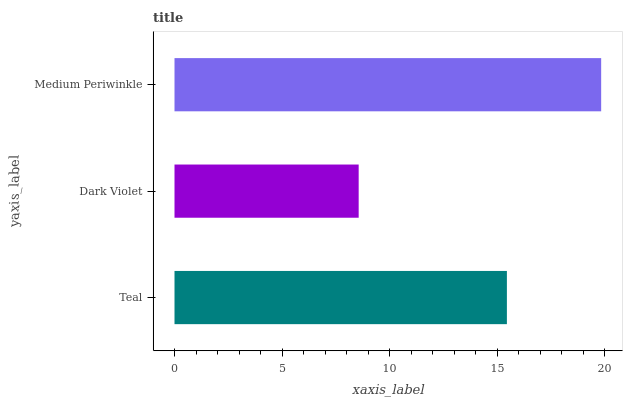Is Dark Violet the minimum?
Answer yes or no. Yes. Is Medium Periwinkle the maximum?
Answer yes or no. Yes. Is Medium Periwinkle the minimum?
Answer yes or no. No. Is Dark Violet the maximum?
Answer yes or no. No. Is Medium Periwinkle greater than Dark Violet?
Answer yes or no. Yes. Is Dark Violet less than Medium Periwinkle?
Answer yes or no. Yes. Is Dark Violet greater than Medium Periwinkle?
Answer yes or no. No. Is Medium Periwinkle less than Dark Violet?
Answer yes or no. No. Is Teal the high median?
Answer yes or no. Yes. Is Teal the low median?
Answer yes or no. Yes. Is Medium Periwinkle the high median?
Answer yes or no. No. Is Dark Violet the low median?
Answer yes or no. No. 